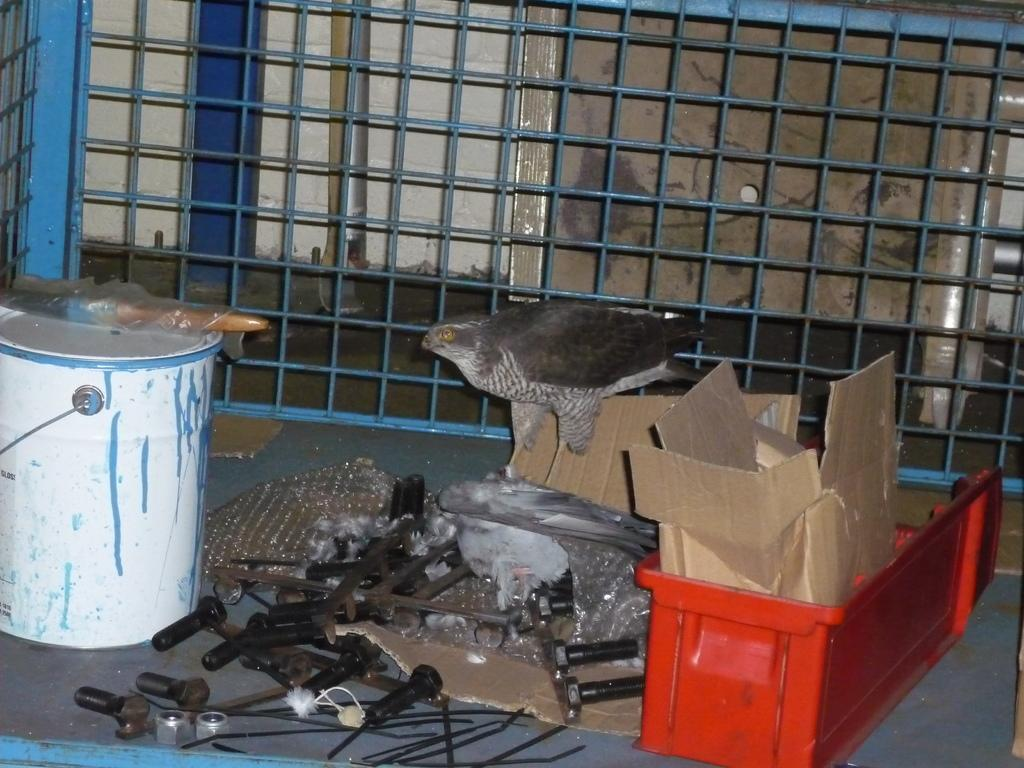What objects can be seen on the ground in the image? There are tools on the ground in the image. What other items are present in the image besides the tools? There are cardboard boxes and a paintbox in the image. Can you describe the bird in the image? There is a bird in the image, but no specific details about the bird are provided. What can be seen in the background of the image? There is a grille visible in the background of the image. How many eggs are in the paintbox in the image? There are no eggs mentioned or visible in the paintbox in the image. 